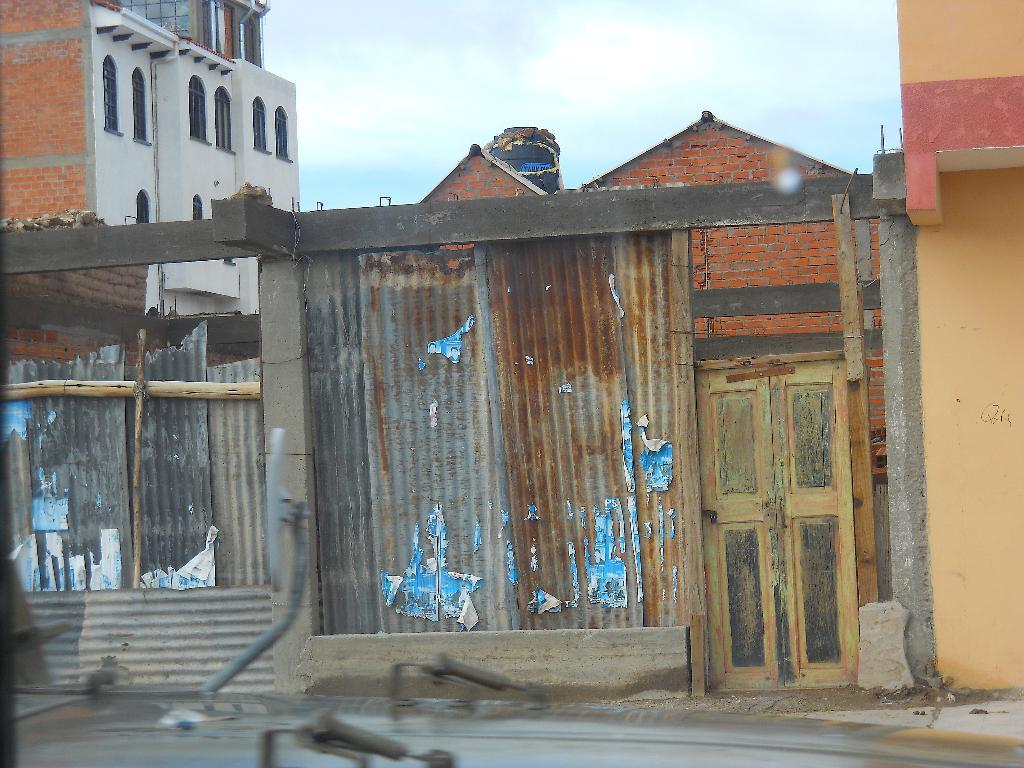In one or two sentences, can you explain what this image depicts? In this image I see few iron sheets, which got rusted a bit and a door. In the background I see a building and a sky. 